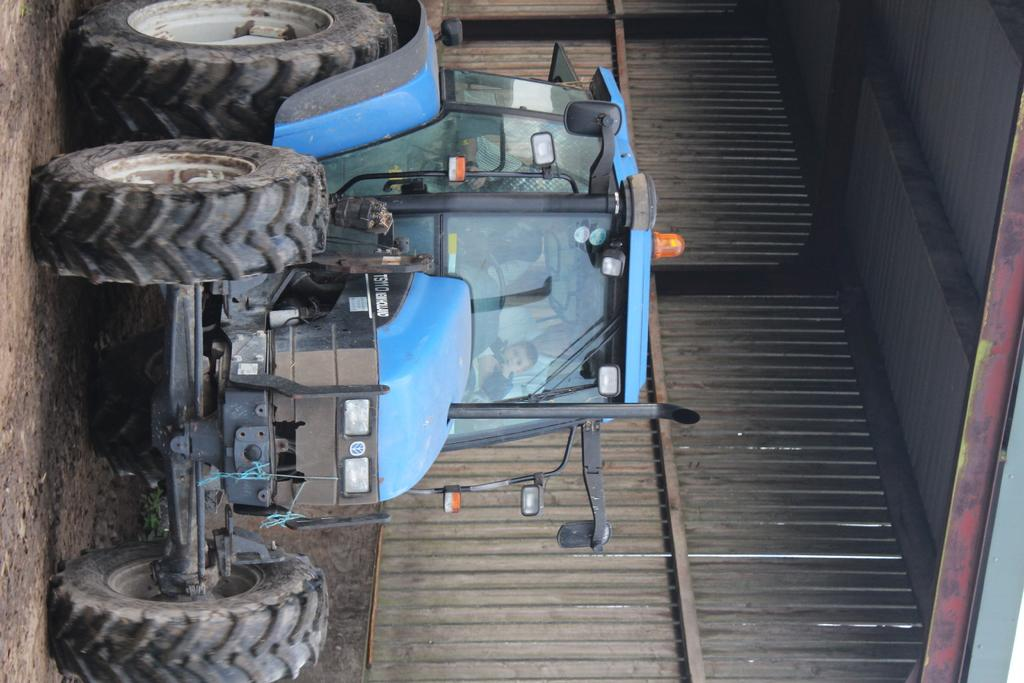What is the main subject of the image? The main subject of the image is a blue vehicle under a shed. Can you describe the people inside the vehicle? Unfortunately, the facts provided do not give any details about the people inside the vehicle. What type of structure is the shed made of? The facts provided do not specify the material of the shed. What can be seen in the background of the image? There is a metal wall in the image. What type of steam is coming out of the basket in the image? There is no basket present in the image, so it is not possible to determine what type of steam might be coming out of it. 